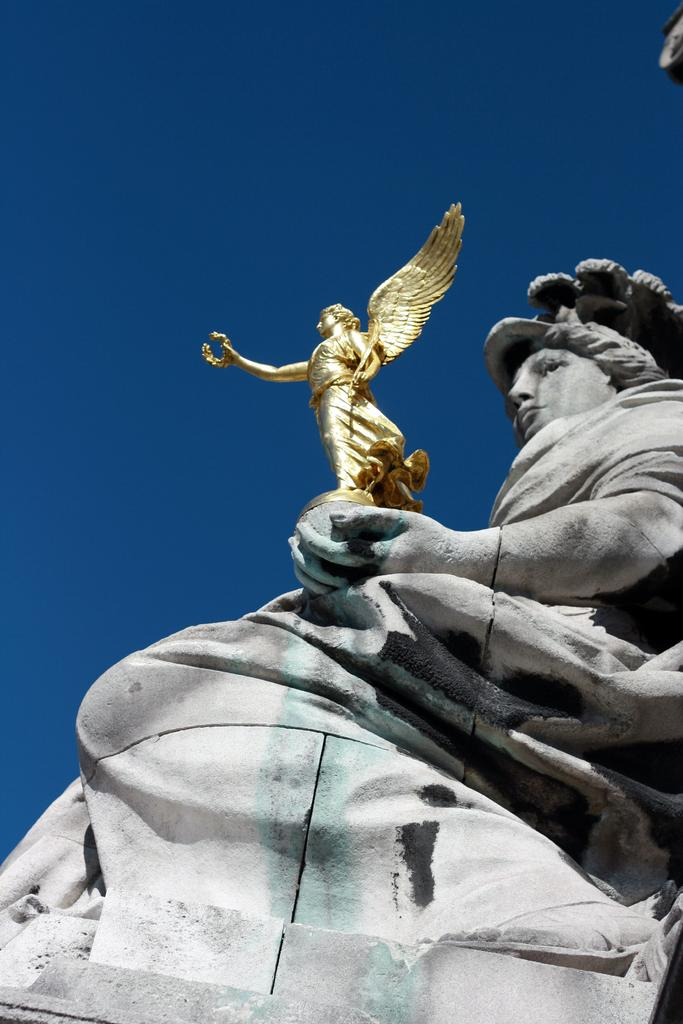What type of objects can be seen in the image? There are statues in the image. What part of the natural environment is visible in the image? The sky is visible in the image. What type of tray is being used by the aunt in the image? There is no aunt or tray present in the image; it only features statues and the sky. 